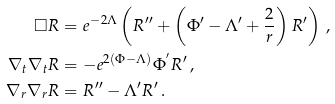<formula> <loc_0><loc_0><loc_500><loc_500>\square R & = e ^ { - 2 \Lambda } \left ( R ^ { \prime \prime } + \left ( \Phi { ^ { \prime } } - \Lambda { ^ { \prime } } + \frac { 2 } { r } \right ) R ^ { \prime } \right ) \, , \\ \nabla _ { t } \nabla _ { t } R & = - e ^ { 2 ( \Phi - \Lambda ) } \Phi ^ { ^ { \prime } } R ^ { \prime } \, , \\ \nabla _ { r } \nabla _ { r } R & = R ^ { \prime \prime } - \Lambda { ^ { \prime } } R ^ { \prime } \, .</formula> 